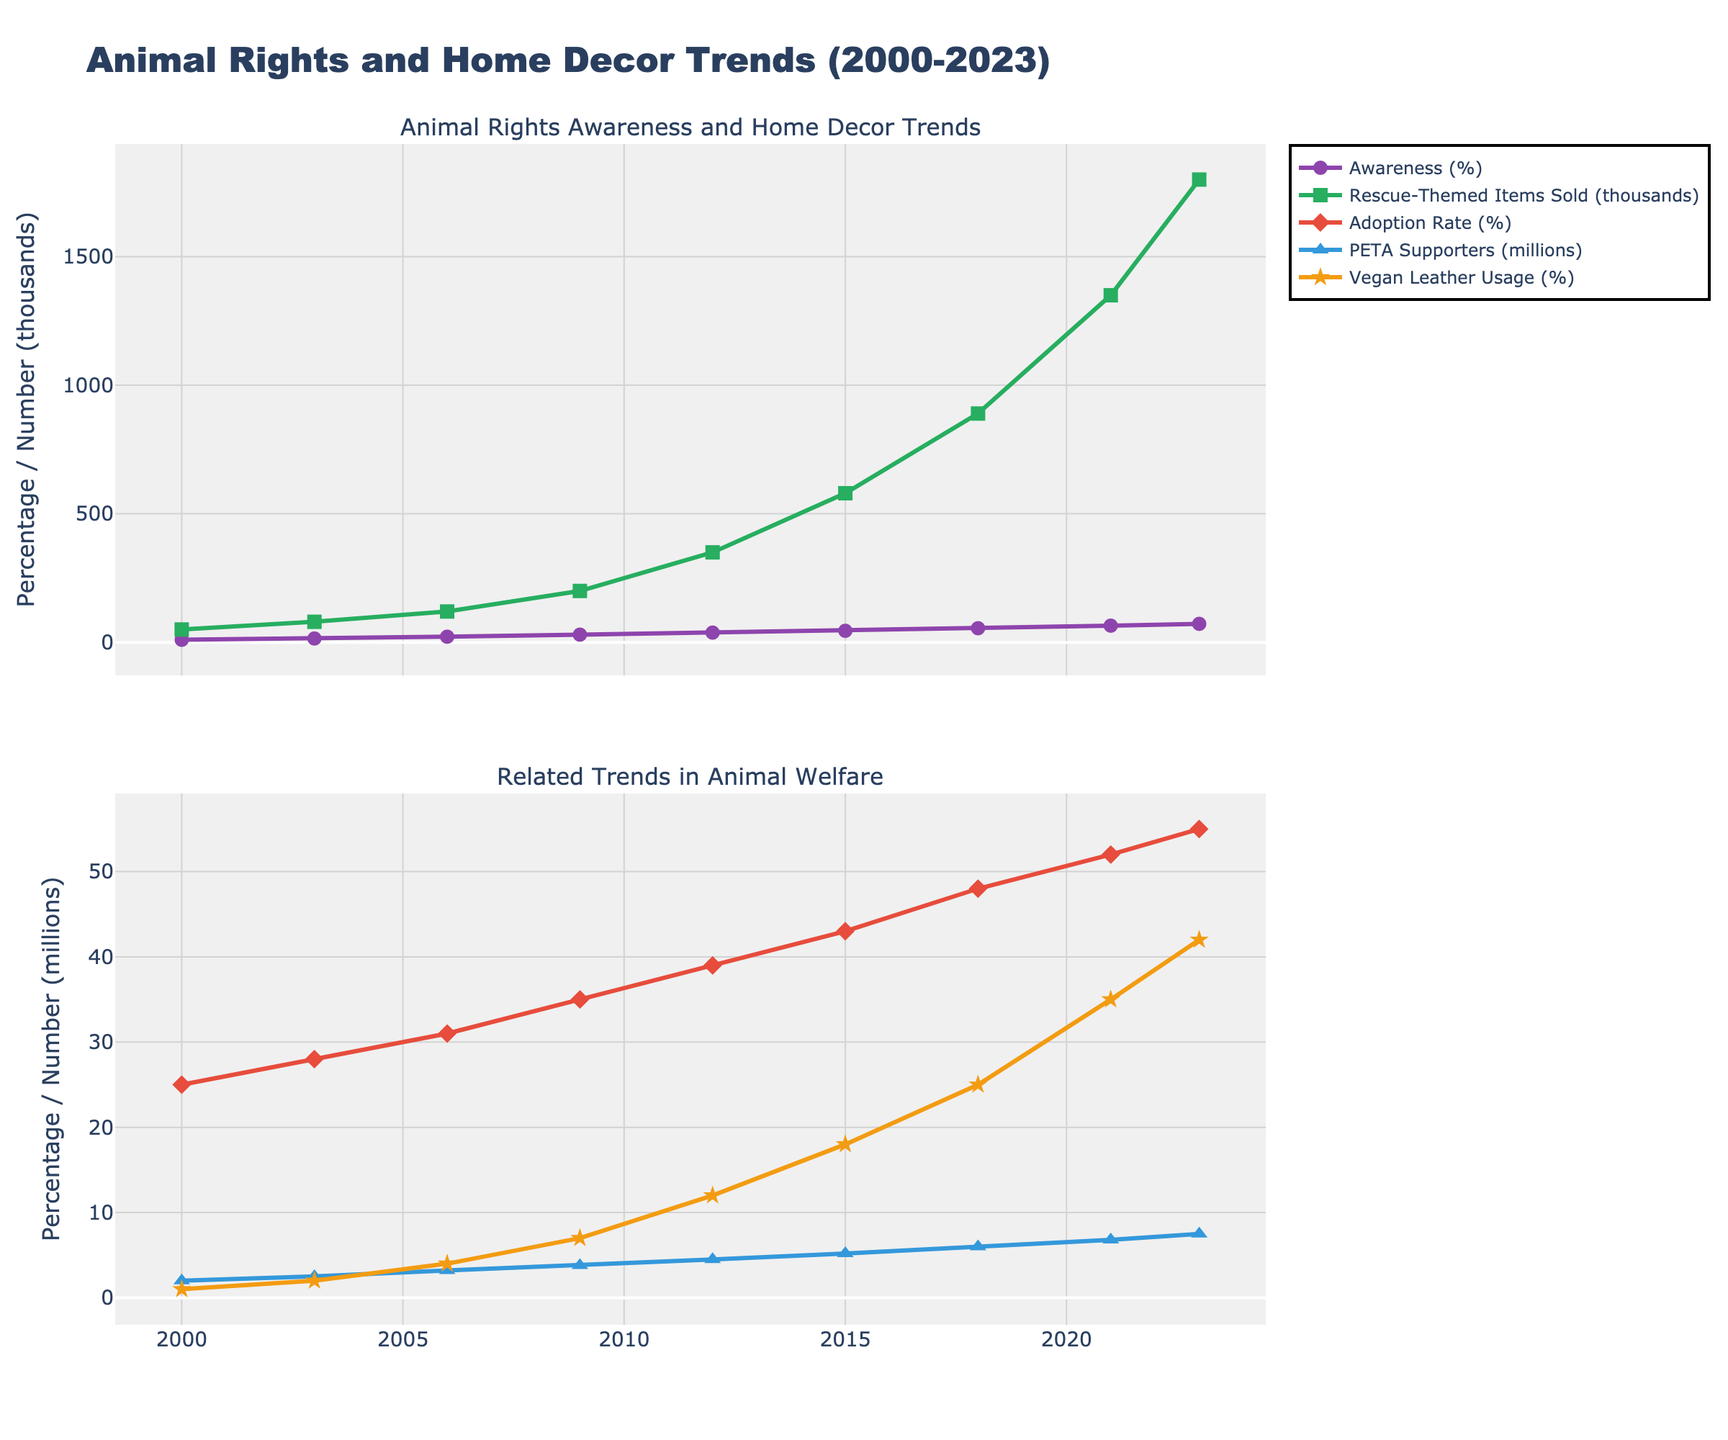what trend is observed in the percentage of people aware of animal rights in home decor from 2000 to 2023? The percentage of people aware of animal rights in home decor trends is shown on the first subplot with a line through different years. The chart shows a steady increase in this percentage from 2000 to 2023.
Answer: Steady increase compare the number of rescue animal-themed home decor items sold in 2009 with 2015. The number of rescue animal-themed home decor items sold, as shown in the first subplot, increased from 200,000 in 2009 to 580,000 in 2015.
Answer: Increased how does the adoption rate from animal shelters in 2015 compare to that in 2000? The adoption rate from animal shelters, depicted in the second subplot, increased from 25% in 2000 to 43% in 2015.
Answer: Increased what visual patterns do you notice in the trends of vegan leather usage in furniture vs. the percentage of people aware of animal rights in home decor? Both trends, represented by different lines in the plots, show a consistent upward trend from 2000 to 2023. Vegan leather usage in furniture and public awareness about animal rights in home decor are both increasing over time.
Answer: Both increasing calculate the average increase per year in PETA supporters from 2000 to 2023. To find the average increase per year, subtract the PETA supporters in 2000 from the PETA supporters in 2023, then divide by the number of years (23): (7.5 - 2.0) / 23 ≈ 0.239 million per year.
Answer: 0.239 million per year compare visually the gap between the adoption rate from animal shelters and the percentage of vegan leather usage in furniture in 2021. In the second subplot, the adoption rate (52%) is shown higher than the percentage of vegan leather usage in furniture (35%), showing a clear visual gap.
Answer: Adoption rate higher what is the overall trend in the data related to animal rights? Across all plots, all variables related to animal rights (e.g., awareness, themed home decor items sold, adoption rate, PETA supporters, vegan leather usage) show an upward trend from 2000 to 2023.
Answer: Upward trend what year saw the largest jump in the number of rescue animal-themed home decor items sold? By looking at the sharpest upward slope in the first subplot, the year 2021 saw the largest jump in the number of rescue animal-themed home decor items sold, from 890,000 in 2018 to 1,350,000 in 2021.
Answer: 2021 compare the percentage trend of adoption rate from animal shelters with that of PETA supporters. In the second subplot, both the adoption rate from animal shelters and the number of PETA supporters show a similar upward trend, indicating increased animal rights awareness and support over time.
Answer: Similar upward trend 